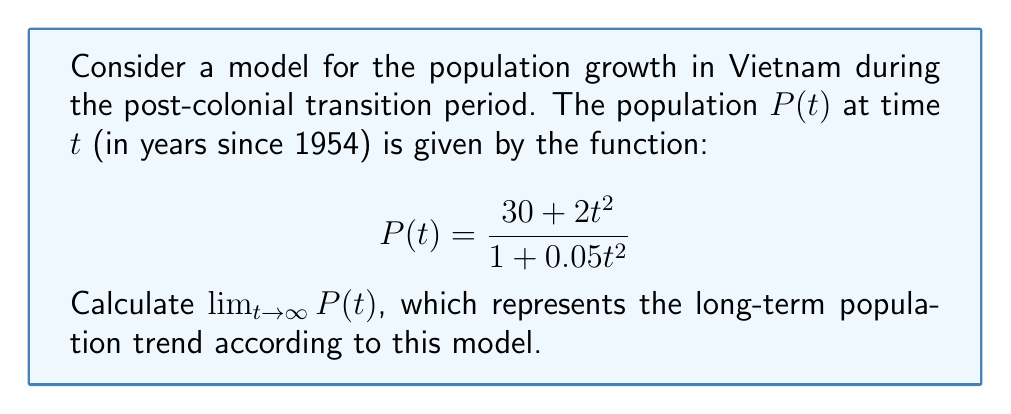Help me with this question. To find the limit of $P(t)$ as $t$ approaches infinity, we need to analyze the behavior of the numerator and denominator separately:

1) First, let's examine the degrees of the polynomials in the numerator and denominator:
   Numerator: $30 + 2t^2$ (degree 2)
   Denominator: $1 + 0.05t^2$ (degree 2)

2) When $t$ approaches infinity, the highest degree terms will dominate. So we can simplify:

   $$\lim_{t \to \infty} P(t) = \lim_{t \to \infty} \frac{30 + 2t^2}{1 + 0.05t^2} = \lim_{t \to \infty} \frac{2t^2}{0.05t^2}$$

3) Now we can cancel $t^2$ from numerator and denominator:

   $$\lim_{t \to \infty} P(t) = \lim_{t \to \infty} \frac{2}{0.05} = \frac{2}{0.05}$$

4) Simplify the fraction:

   $$\frac{2}{0.05} = \frac{2 \times 100}{5} = \frac{200}{5} = 40$$

Therefore, the limit of the population as time approaches infinity is 40 million.

This result suggests that, according to this model, the population of Vietnam would stabilize around 40 million in the long term. However, it's important to note that real-world population dynamics are much more complex and influenced by many factors not captured in this simplified model.
Answer: $\lim_{t \to \infty} P(t) = 40$ million 